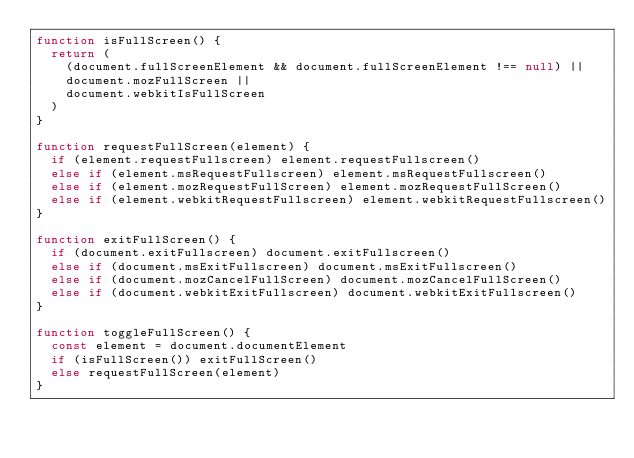Convert code to text. <code><loc_0><loc_0><loc_500><loc_500><_JavaScript_>function isFullScreen() {
  return (
    (document.fullScreenElement && document.fullScreenElement !== null) ||
    document.mozFullScreen ||
    document.webkitIsFullScreen
  )
}

function requestFullScreen(element) {
  if (element.requestFullscreen) element.requestFullscreen()
  else if (element.msRequestFullscreen) element.msRequestFullscreen()
  else if (element.mozRequestFullScreen) element.mozRequestFullScreen()
  else if (element.webkitRequestFullscreen) element.webkitRequestFullscreen()
}

function exitFullScreen() {
  if (document.exitFullscreen) document.exitFullscreen()
  else if (document.msExitFullscreen) document.msExitFullscreen()
  else if (document.mozCancelFullScreen) document.mozCancelFullScreen()
  else if (document.webkitExitFullscreen) document.webkitExitFullscreen()
}

function toggleFullScreen() {
  const element = document.documentElement
  if (isFullScreen()) exitFullScreen()
  else requestFullScreen(element)
}
</code> 